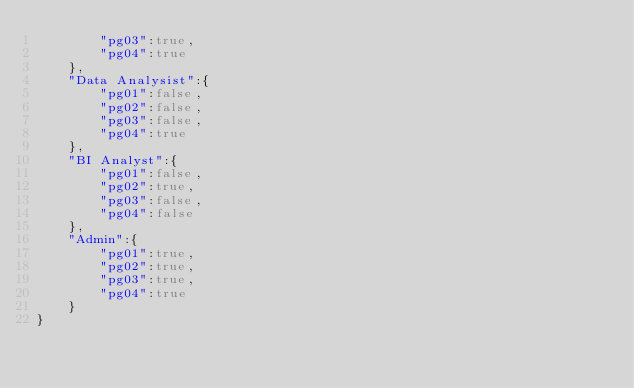Convert code to text. <code><loc_0><loc_0><loc_500><loc_500><_JavaScript_>        "pg03":true,
        "pg04":true
    },
    "Data Analysist":{
        "pg01":false,
        "pg02":false,
        "pg03":false,
        "pg04":true
    },
    "BI Analyst":{
        "pg01":false,
        "pg02":true,
        "pg03":false,
        "pg04":false
    },
    "Admin":{
        "pg01":true,
        "pg02":true,
        "pg03":true,
        "pg04":true
    }
}</code> 